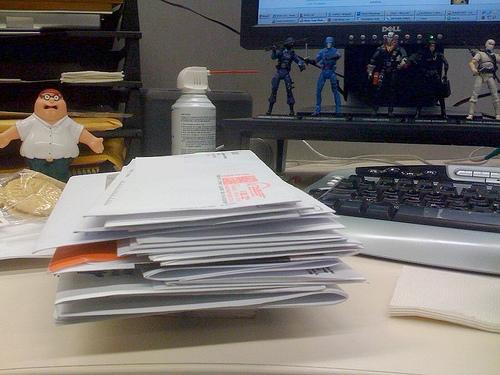Is the keyboard in use?
Give a very brief answer. No. Is this an office desk?
Write a very short answer. Yes. What is the closest thing to the camera?
Be succinct. Mail. What kind of weapons do the toys hold?
Write a very short answer. Swords. 